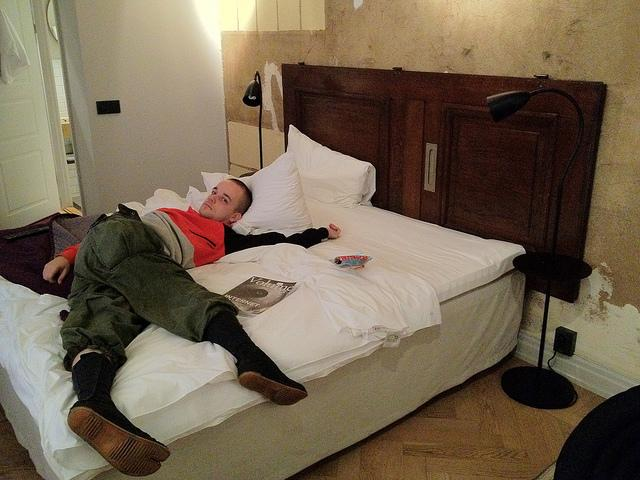What is next to the bed? lamp 